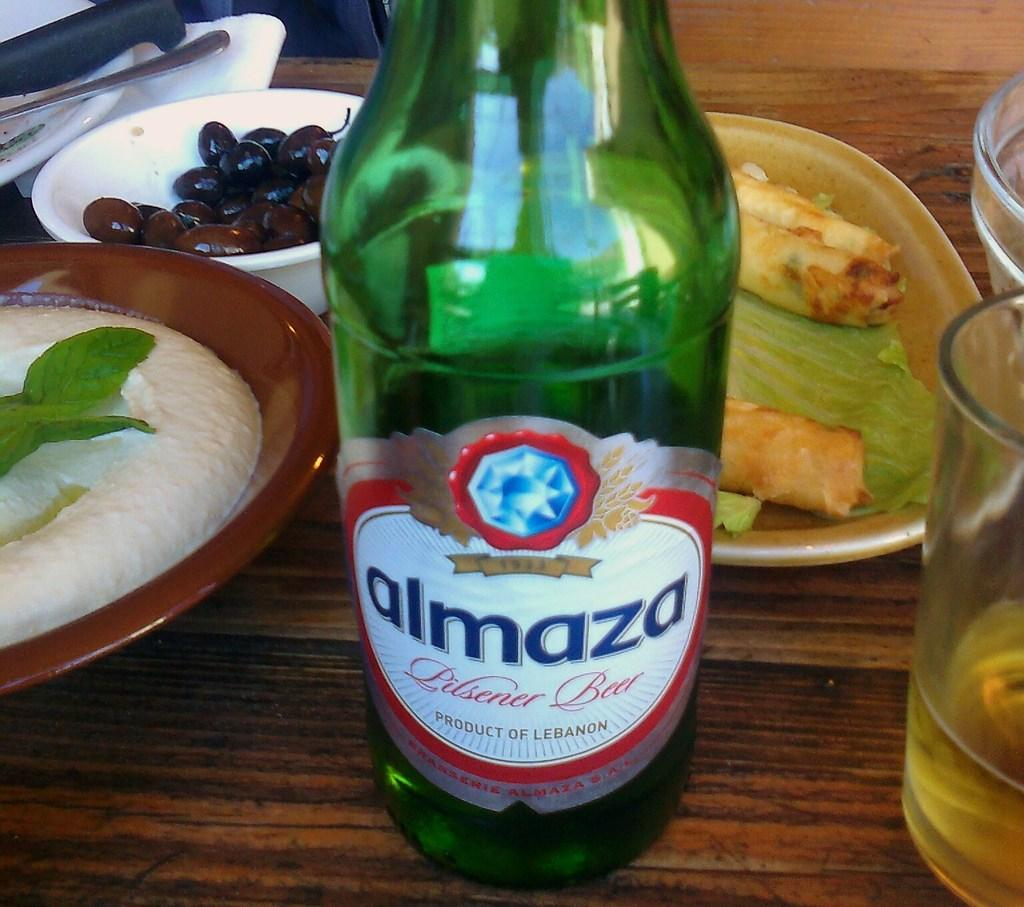Provide a one-sentence caption for the provided image. A green bottle of Almaza beer sits on a table. 